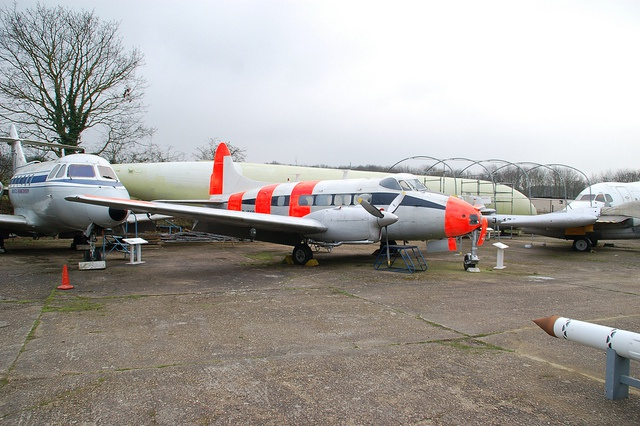Describe the objects in this image and their specific colors. I can see airplane in lightgray, black, darkgray, and gray tones, airplane in lightgray, black, gray, and darkgray tones, airplane in lightgray and darkgray tones, airplane in lightgray, black, darkgray, and gray tones, and airplane in lightgray, darkgray, and gray tones in this image. 